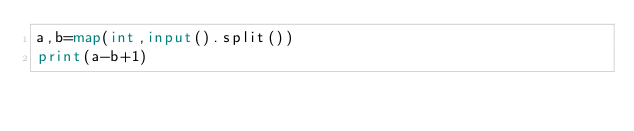<code> <loc_0><loc_0><loc_500><loc_500><_Python_>a,b=map(int,input().split())
print(a-b+1)</code> 